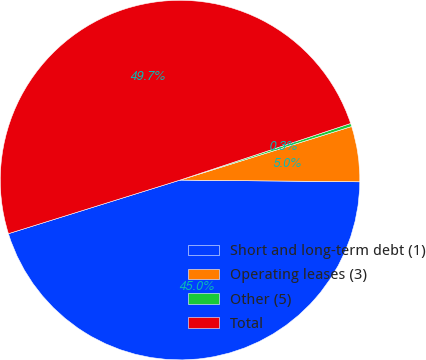Convert chart to OTSL. <chart><loc_0><loc_0><loc_500><loc_500><pie_chart><fcel>Short and long-term debt (1)<fcel>Operating leases (3)<fcel>Other (5)<fcel>Total<nl><fcel>45.03%<fcel>4.97%<fcel>0.28%<fcel>49.72%<nl></chart> 